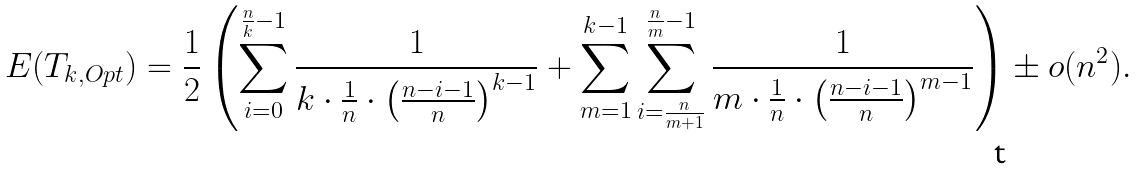<formula> <loc_0><loc_0><loc_500><loc_500>E ( T _ { k , O p t } ) & = \frac { 1 } { 2 } \left ( \sum _ { i = 0 } ^ { \frac { n } { k } - 1 } \frac { 1 } { k \cdot \frac { 1 } { n } \cdot \left ( \frac { n - i - 1 } { n } \right ) ^ { k - 1 } } + \sum _ { m = 1 } ^ { k - 1 } \sum _ { i = \frac { n } { m + 1 } } ^ { \frac { n } { m } - 1 } \frac { 1 } { m \cdot \frac { 1 } { n } \cdot \left ( \frac { n - i - 1 } { n } \right ) ^ { m - 1 } } \right ) \pm o ( n ^ { 2 } ) .</formula> 